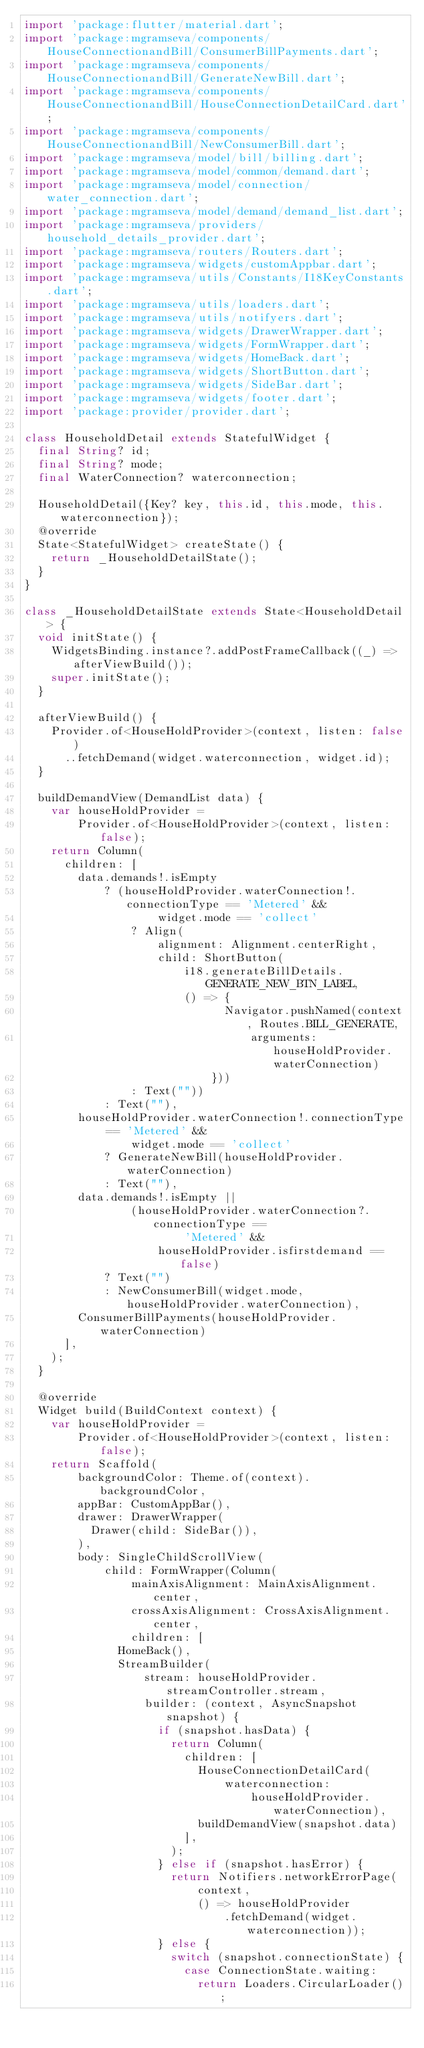<code> <loc_0><loc_0><loc_500><loc_500><_Dart_>import 'package:flutter/material.dart';
import 'package:mgramseva/components/HouseConnectionandBill/ConsumerBillPayments.dart';
import 'package:mgramseva/components/HouseConnectionandBill/GenerateNewBill.dart';
import 'package:mgramseva/components/HouseConnectionandBill/HouseConnectionDetailCard.dart';
import 'package:mgramseva/components/HouseConnectionandBill/NewConsumerBill.dart';
import 'package:mgramseva/model/bill/billing.dart';
import 'package:mgramseva/model/common/demand.dart';
import 'package:mgramseva/model/connection/water_connection.dart';
import 'package:mgramseva/model/demand/demand_list.dart';
import 'package:mgramseva/providers/household_details_provider.dart';
import 'package:mgramseva/routers/Routers.dart';
import 'package:mgramseva/widgets/customAppbar.dart';
import 'package:mgramseva/utils/Constants/I18KeyConstants.dart';
import 'package:mgramseva/utils/loaders.dart';
import 'package:mgramseva/utils/notifyers.dart';
import 'package:mgramseva/widgets/DrawerWrapper.dart';
import 'package:mgramseva/widgets/FormWrapper.dart';
import 'package:mgramseva/widgets/HomeBack.dart';
import 'package:mgramseva/widgets/ShortButton.dart';
import 'package:mgramseva/widgets/SideBar.dart';
import 'package:mgramseva/widgets/footer.dart';
import 'package:provider/provider.dart';

class HouseholdDetail extends StatefulWidget {
  final String? id;
  final String? mode;
  final WaterConnection? waterconnection;

  HouseholdDetail({Key? key, this.id, this.mode, this.waterconnection});
  @override
  State<StatefulWidget> createState() {
    return _HouseholdDetailState();
  }
}

class _HouseholdDetailState extends State<HouseholdDetail> {
  void initState() {
    WidgetsBinding.instance?.addPostFrameCallback((_) => afterViewBuild());
    super.initState();
  }

  afterViewBuild() {
    Provider.of<HouseHoldProvider>(context, listen: false)
      ..fetchDemand(widget.waterconnection, widget.id);
  }

  buildDemandView(DemandList data) {
    var houseHoldProvider =
        Provider.of<HouseHoldProvider>(context, listen: false);
    return Column(
      children: [
        data.demands!.isEmpty
            ? (houseHoldProvider.waterConnection!.connectionType == 'Metered' &&
                    widget.mode == 'collect'
                ? Align(
                    alignment: Alignment.centerRight,
                    child: ShortButton(
                        i18.generateBillDetails.GENERATE_NEW_BTN_LABEL,
                        () => {
                              Navigator.pushNamed(context, Routes.BILL_GENERATE,
                                  arguments: houseHoldProvider.waterConnection)
                            }))
                : Text(""))
            : Text(""),
        houseHoldProvider.waterConnection!.connectionType == 'Metered' &&
                widget.mode == 'collect'
            ? GenerateNewBill(houseHoldProvider.waterConnection)
            : Text(""),
        data.demands!.isEmpty ||
                (houseHoldProvider.waterConnection?.connectionType ==
                        'Metered' &&
                    houseHoldProvider.isfirstdemand == false)
            ? Text("")
            : NewConsumerBill(widget.mode, houseHoldProvider.waterConnection),
        ConsumerBillPayments(houseHoldProvider.waterConnection)
      ],
    );
  }

  @override
  Widget build(BuildContext context) {
    var houseHoldProvider =
        Provider.of<HouseHoldProvider>(context, listen: false);
    return Scaffold(
        backgroundColor: Theme.of(context).backgroundColor,
        appBar: CustomAppBar(),
        drawer: DrawerWrapper(
          Drawer(child: SideBar()),
        ),
        body: SingleChildScrollView(
            child: FormWrapper(Column(
                mainAxisAlignment: MainAxisAlignment.center,
                crossAxisAlignment: CrossAxisAlignment.center,
                children: [
              HomeBack(),
              StreamBuilder(
                  stream: houseHoldProvider.streamController.stream,
                  builder: (context, AsyncSnapshot snapshot) {
                    if (snapshot.hasData) {
                      return Column(
                        children: [
                          HouseConnectionDetailCard(
                              waterconnection:
                                  houseHoldProvider.waterConnection),
                          buildDemandView(snapshot.data)
                        ],
                      );
                    } else if (snapshot.hasError) {
                      return Notifiers.networkErrorPage(
                          context,
                          () => houseHoldProvider
                              .fetchDemand(widget.waterconnection));
                    } else {
                      switch (snapshot.connectionState) {
                        case ConnectionState.waiting:
                          return Loaders.CircularLoader();</code> 